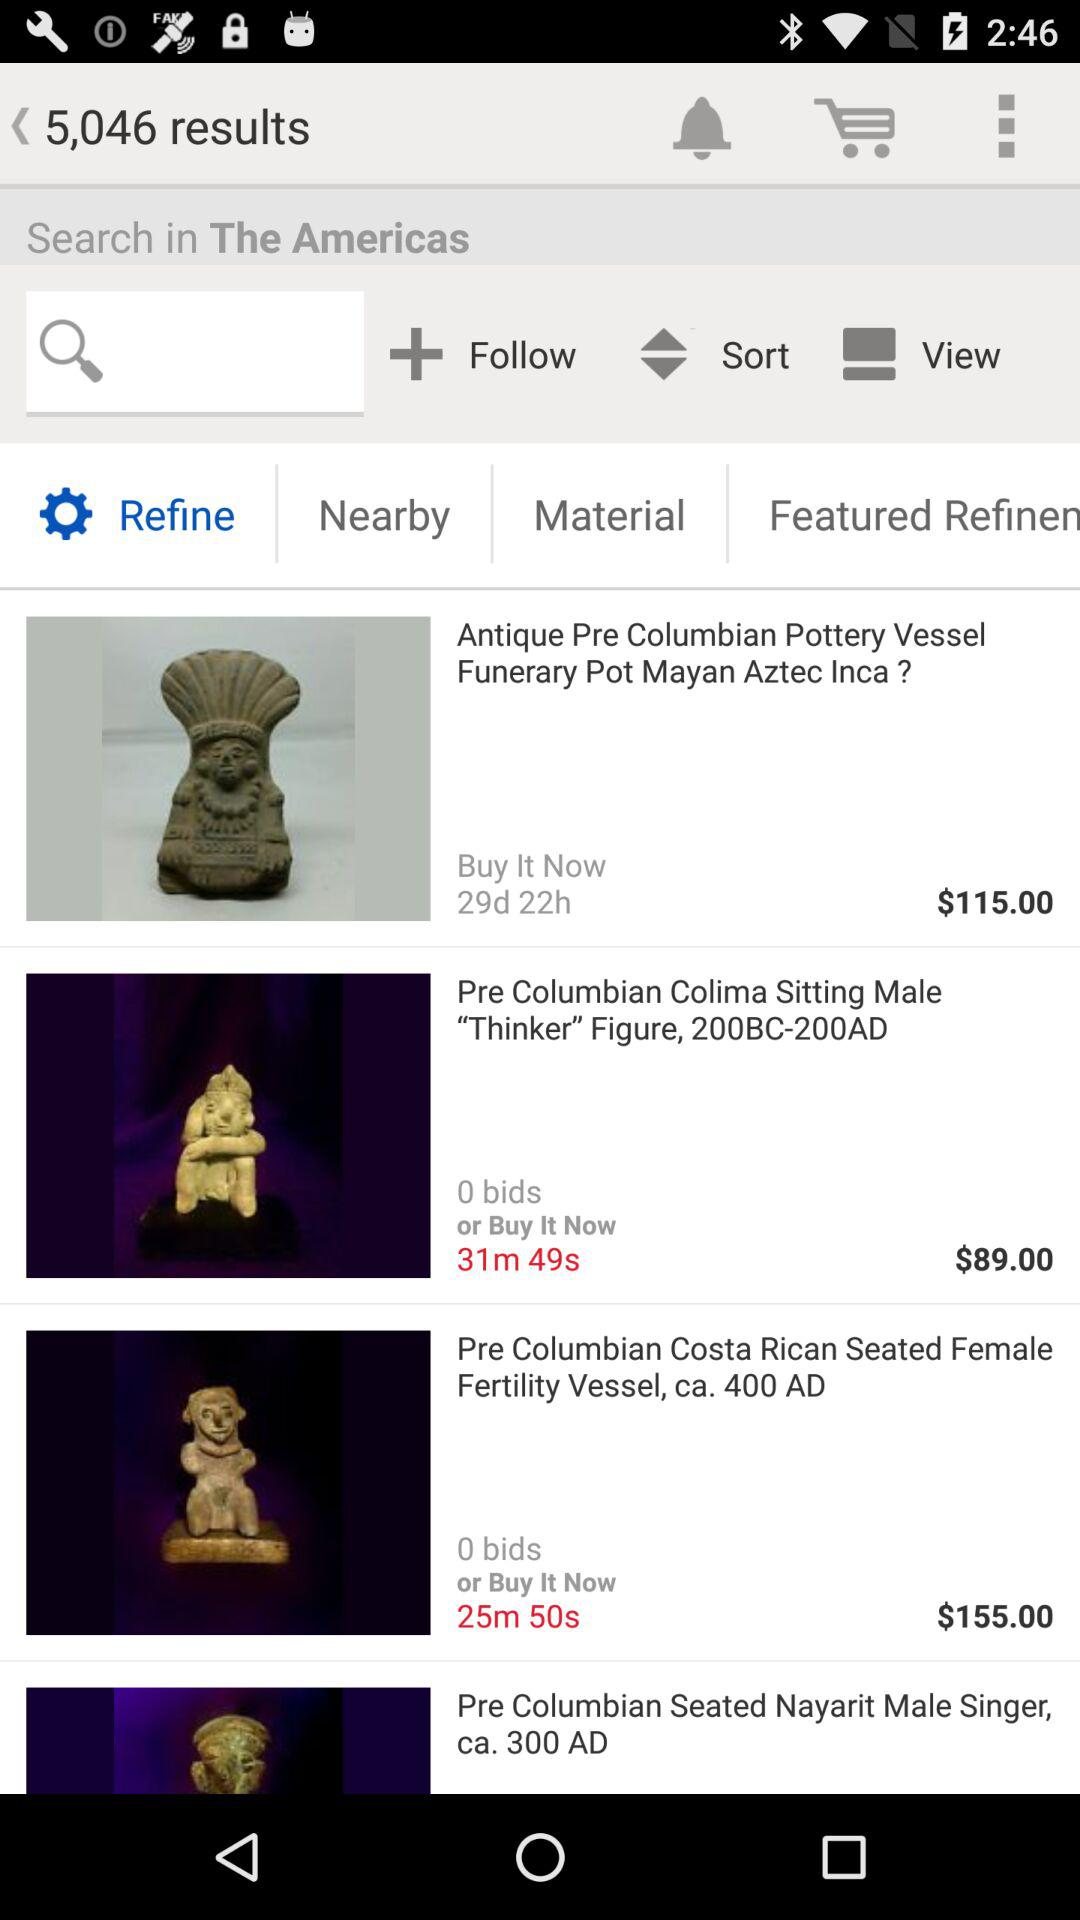What is the price of "Pre Columbian Colima Sitting Male"? The price of "Pre Columbian Colima Sitting Male" is $89. 